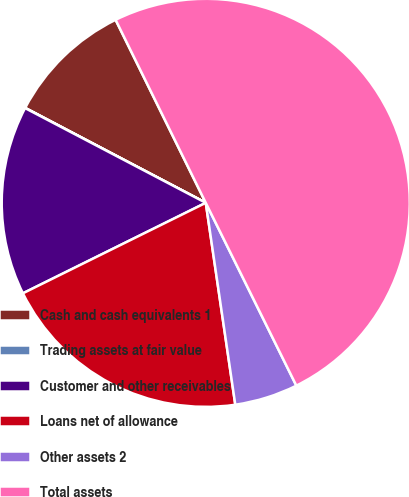Convert chart to OTSL. <chart><loc_0><loc_0><loc_500><loc_500><pie_chart><fcel>Cash and cash equivalents 1<fcel>Trading assets at fair value<fcel>Customer and other receivables<fcel>Loans net of allowance<fcel>Other assets 2<fcel>Total assets<nl><fcel>10.01%<fcel>0.02%<fcel>15.0%<fcel>20.0%<fcel>5.01%<fcel>49.97%<nl></chart> 